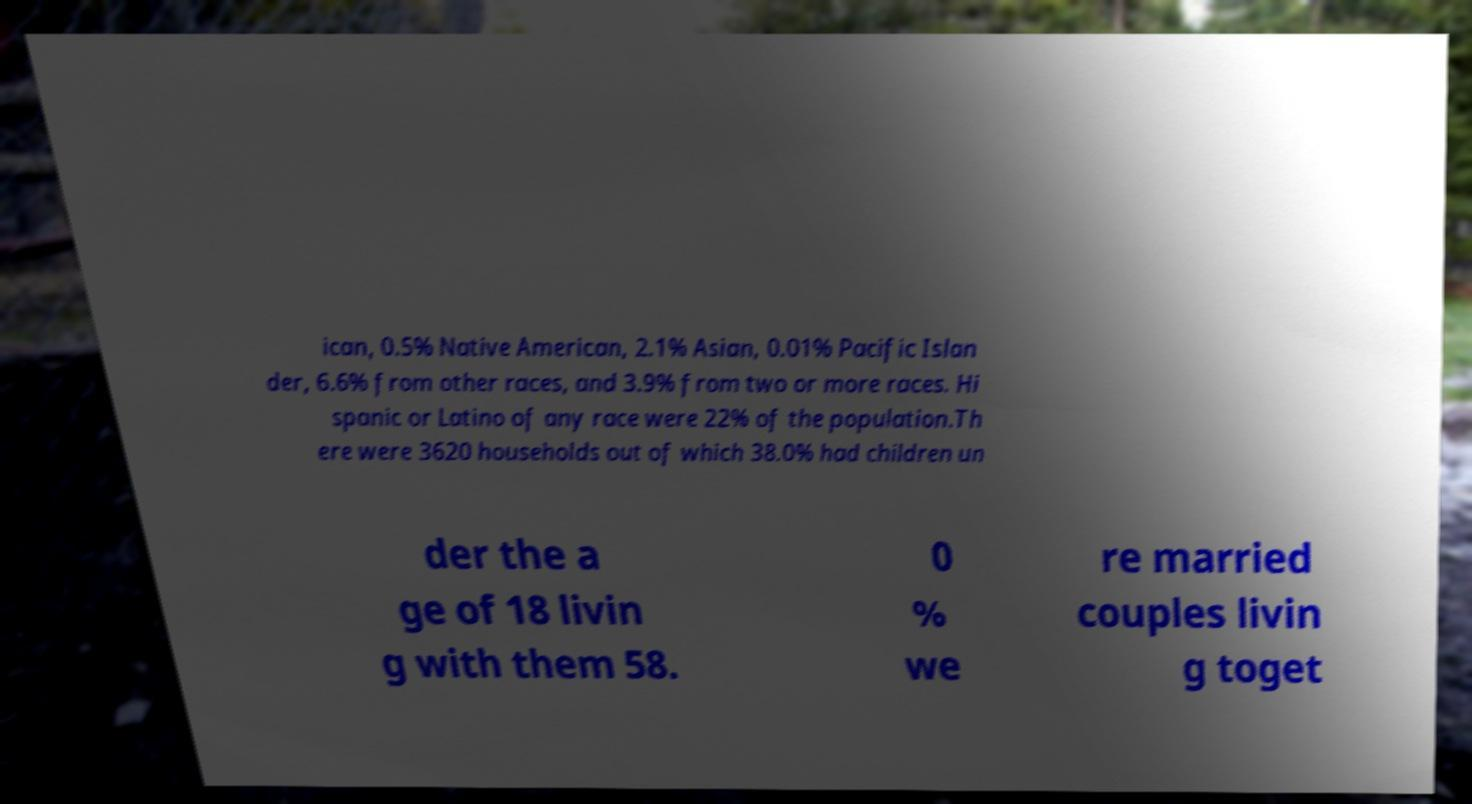Could you assist in decoding the text presented in this image and type it out clearly? ican, 0.5% Native American, 2.1% Asian, 0.01% Pacific Islan der, 6.6% from other races, and 3.9% from two or more races. Hi spanic or Latino of any race were 22% of the population.Th ere were 3620 households out of which 38.0% had children un der the a ge of 18 livin g with them 58. 0 % we re married couples livin g toget 